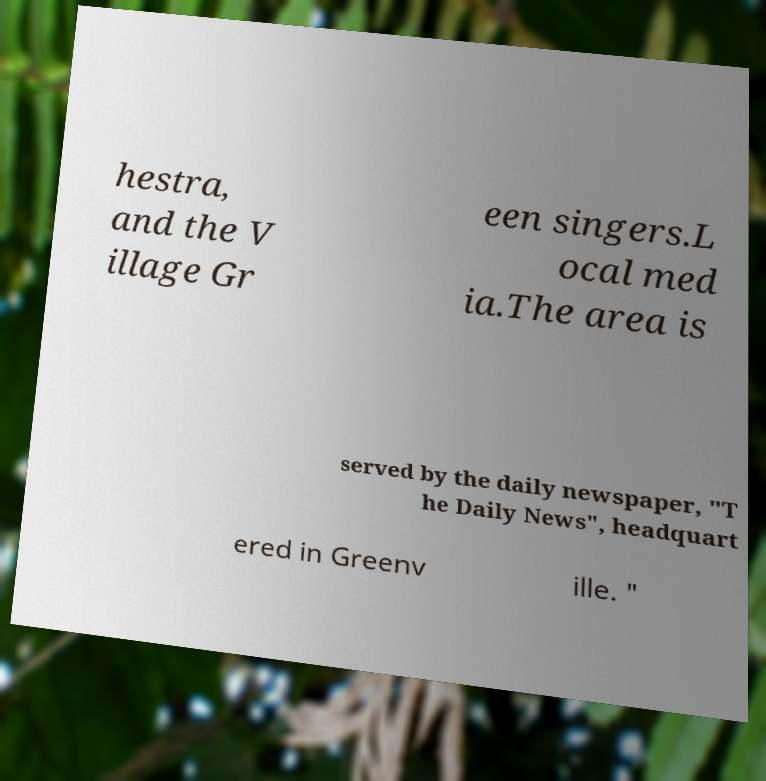I need the written content from this picture converted into text. Can you do that? hestra, and the V illage Gr een singers.L ocal med ia.The area is served by the daily newspaper, "T he Daily News", headquart ered in Greenv ille. " 